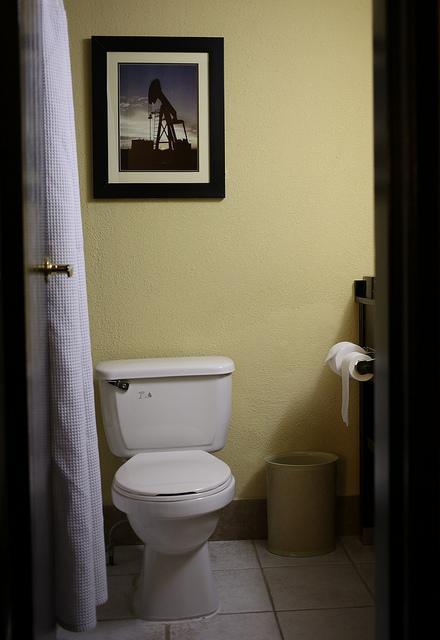How many rolls of Toilet tissue do you see?
Give a very brief answer. 2. 